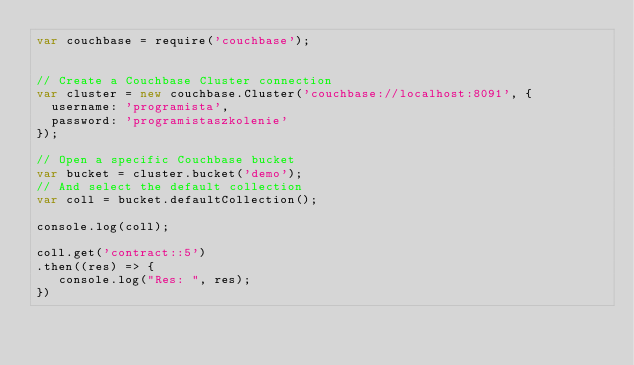Convert code to text. <code><loc_0><loc_0><loc_500><loc_500><_JavaScript_>var couchbase = require('couchbase');


// Create a Couchbase Cluster connection
var cluster = new couchbase.Cluster('couchbase://localhost:8091', {
  username: 'programista',
  password: 'programistaszkolenie'
});

// Open a specific Couchbase bucket
var bucket = cluster.bucket('demo');
// And select the default collection
var coll = bucket.defaultCollection();

console.log(coll);

coll.get('contract::5')
.then((res) => { 
   console.log("Res: ", res); 
})</code> 